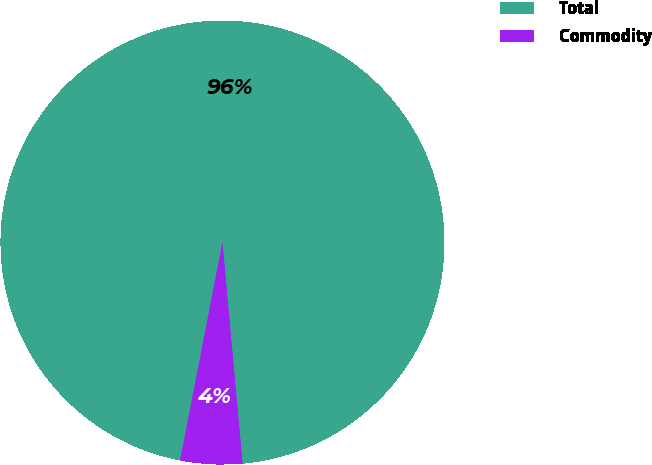Convert chart. <chart><loc_0><loc_0><loc_500><loc_500><pie_chart><fcel>Total<fcel>Commodity<nl><fcel>95.5%<fcel>4.5%<nl></chart> 